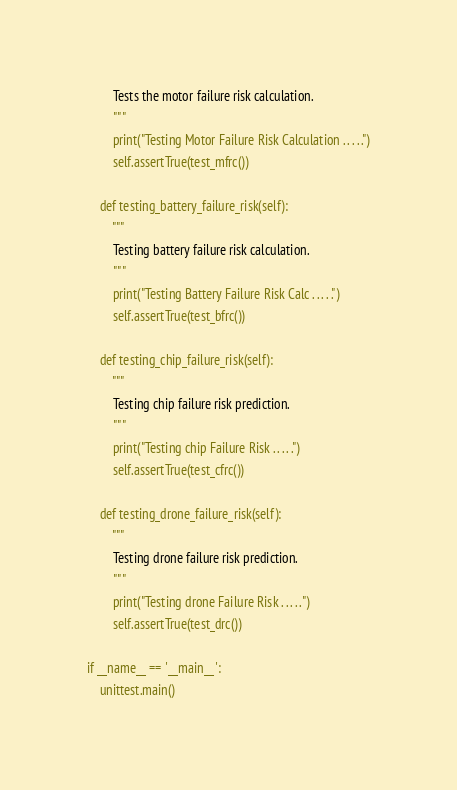<code> <loc_0><loc_0><loc_500><loc_500><_Python_>        Tests the motor failure risk calculation. 
        """
        print("Testing Motor Failure Risk Calculation . . . . .")
        self.assertTrue(test_mfrc())

    def testing_battery_failure_risk(self):
        """
        Testing battery failure risk calculation.
        """
        print("Testing Battery Failure Risk Calc . . . . .")
        self.assertTrue(test_bfrc())
    
    def testing_chip_failure_risk(self):
        """
        Testing chip failure risk prediction.
        """
        print("Testing chip Failure Risk . . . . .")
        self.assertTrue(test_cfrc())
    
    def testing_drone_failure_risk(self):
        """
        Testing drone failure risk prediction.
        """
        print("Testing drone Failure Risk . . . . .")
        self.assertTrue(test_drc())

if __name__ == '__main__':
    unittest.main()

</code> 